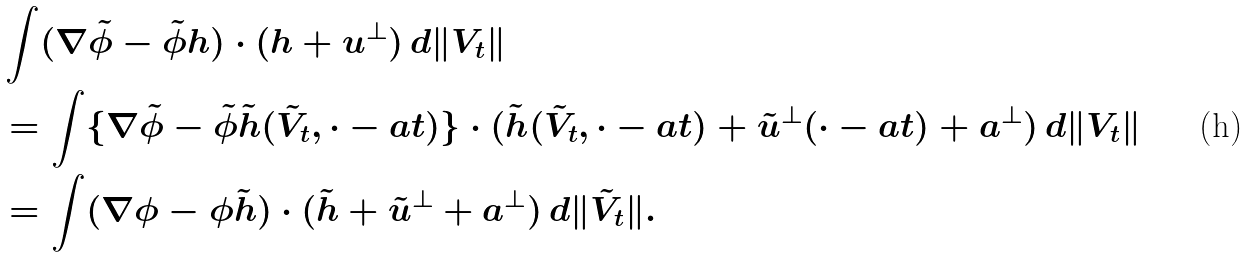Convert formula to latex. <formula><loc_0><loc_0><loc_500><loc_500>& \int ( \nabla \tilde { \phi } - \tilde { \phi } h ) \cdot ( h + u ^ { \perp } ) \, d \| V _ { t } \| \\ & = \int \{ \nabla \tilde { \phi } - \tilde { \phi } \tilde { h } ( \tilde { V } _ { t } , \cdot - a t ) \} \cdot ( \tilde { h } ( \tilde { V } _ { t } , \cdot - a t ) + \tilde { u } ^ { \perp } ( \cdot - a t ) + a ^ { \perp } ) \, d \| V _ { t } \| \\ & = \int ( \nabla \phi - \phi \tilde { h } ) \cdot ( \tilde { h } + \tilde { u } ^ { \perp } + a ^ { \perp } ) \, d \| \tilde { V } _ { t } \| .</formula> 